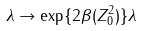<formula> <loc_0><loc_0><loc_500><loc_500>\lambda \rightarrow \exp \{ 2 \beta ( Z _ { 0 } ^ { 2 } ) \} \lambda</formula> 